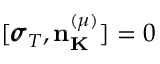Convert formula to latex. <formula><loc_0><loc_0><loc_500><loc_500>[ { \pm b \sigma } _ { T } , { n } _ { K } ^ { ( \mu ) } ] = 0</formula> 